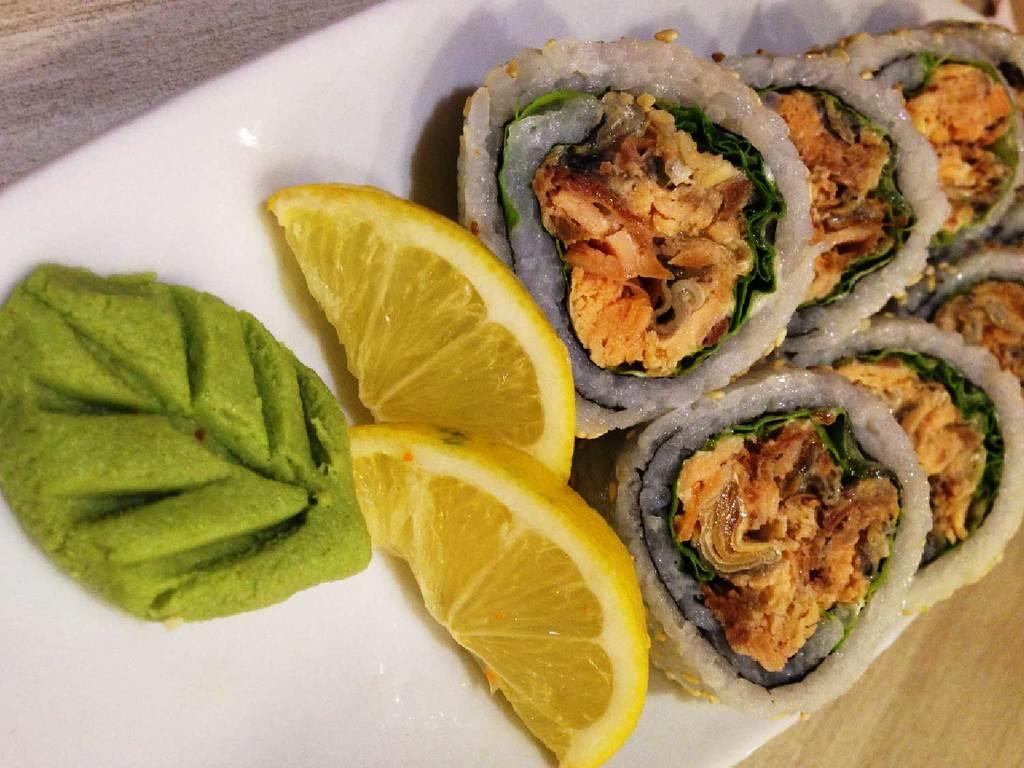What type of food can be seen in the image? There is food in the image, but the specific type is not mentioned. What additional items are present with the food? Lemon slices are present in the image. Where are the food and lemon slices located? The food and lemon slices are in a white tray. What type of surface is visible in the bottom right corner of the image? There is a wooden surface in the bottom right corner of the image. How many houses can be seen through the window in the image? There is no window or houses present in the image. What type of pull mechanism is used to open the wooden surface in the image? There is no pull mechanism mentioned or visible in the image, as it only shows a wooden surface in the bottom right corner. 